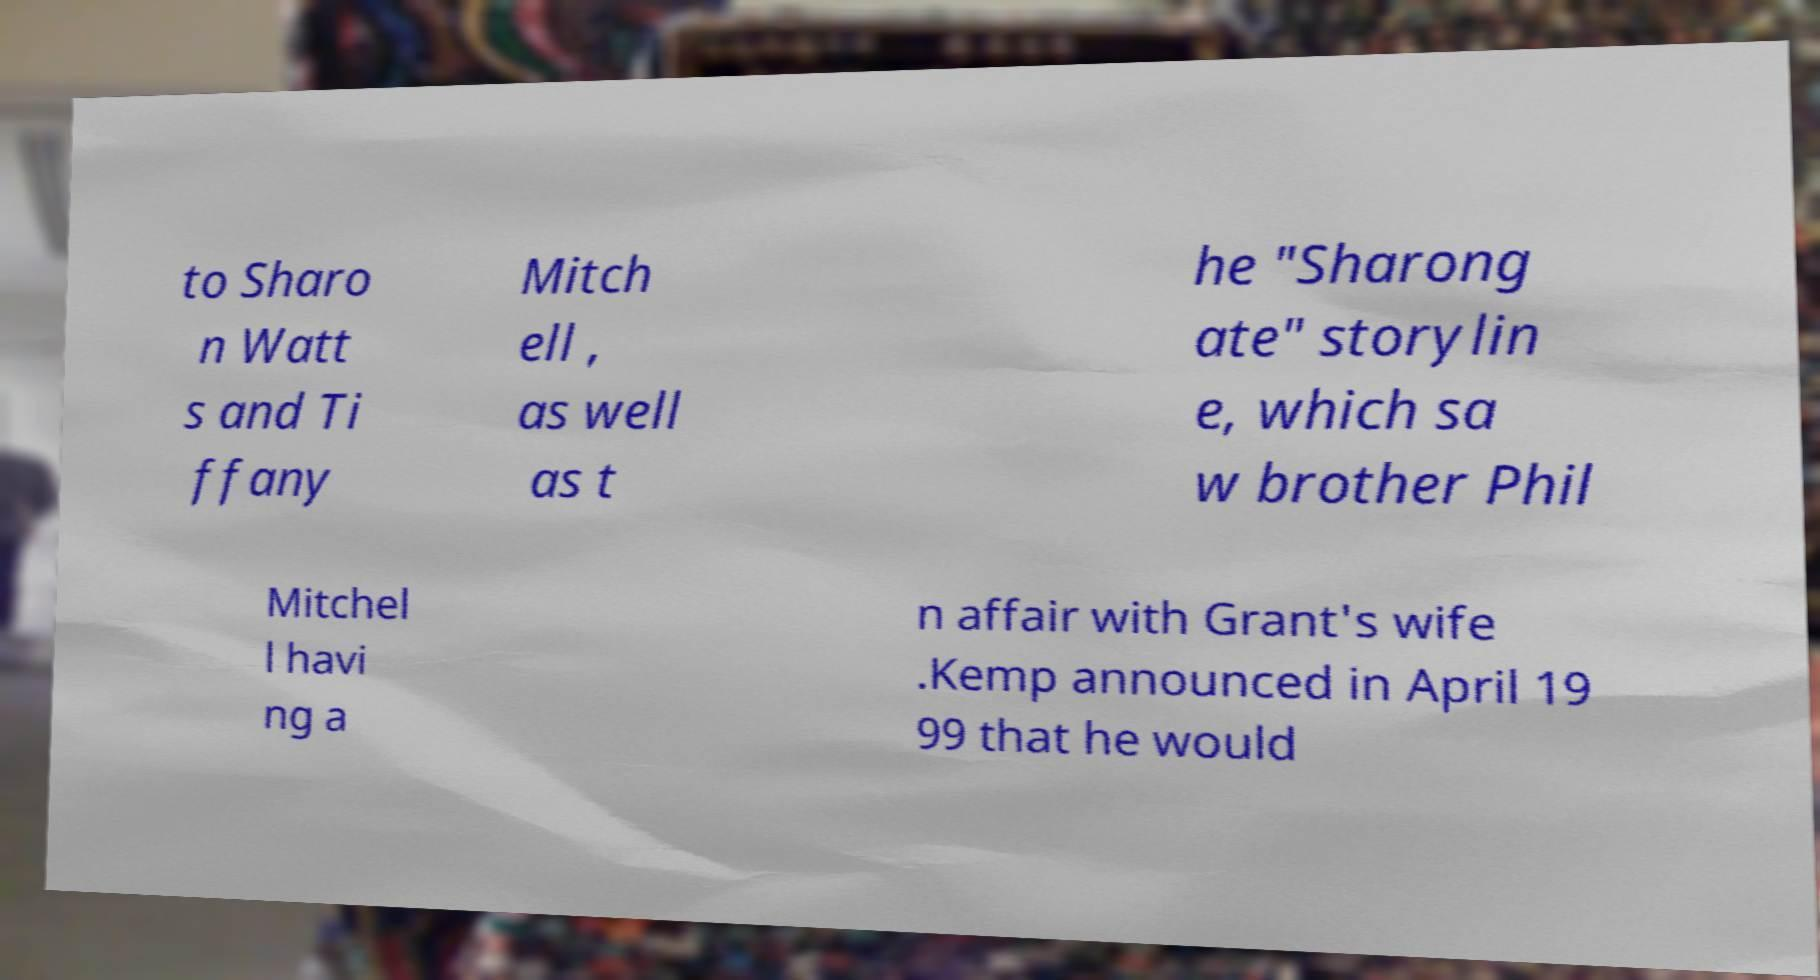I need the written content from this picture converted into text. Can you do that? to Sharo n Watt s and Ti ffany Mitch ell , as well as t he "Sharong ate" storylin e, which sa w brother Phil Mitchel l havi ng a n affair with Grant's wife .Kemp announced in April 19 99 that he would 